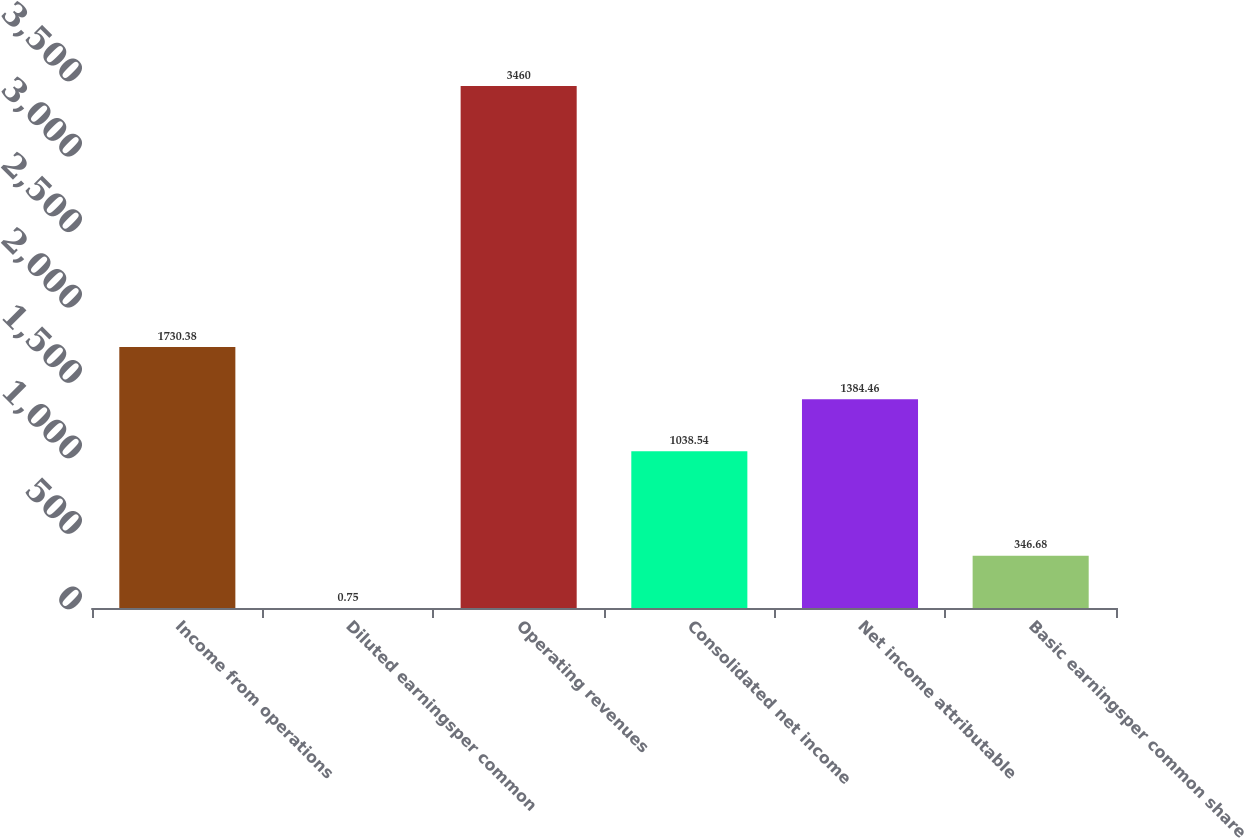<chart> <loc_0><loc_0><loc_500><loc_500><bar_chart><fcel>Income from operations<fcel>Diluted earningsper common<fcel>Operating revenues<fcel>Consolidated net income<fcel>Net income attributable<fcel>Basic earningsper common share<nl><fcel>1730.38<fcel>0.75<fcel>3460<fcel>1038.54<fcel>1384.46<fcel>346.68<nl></chart> 